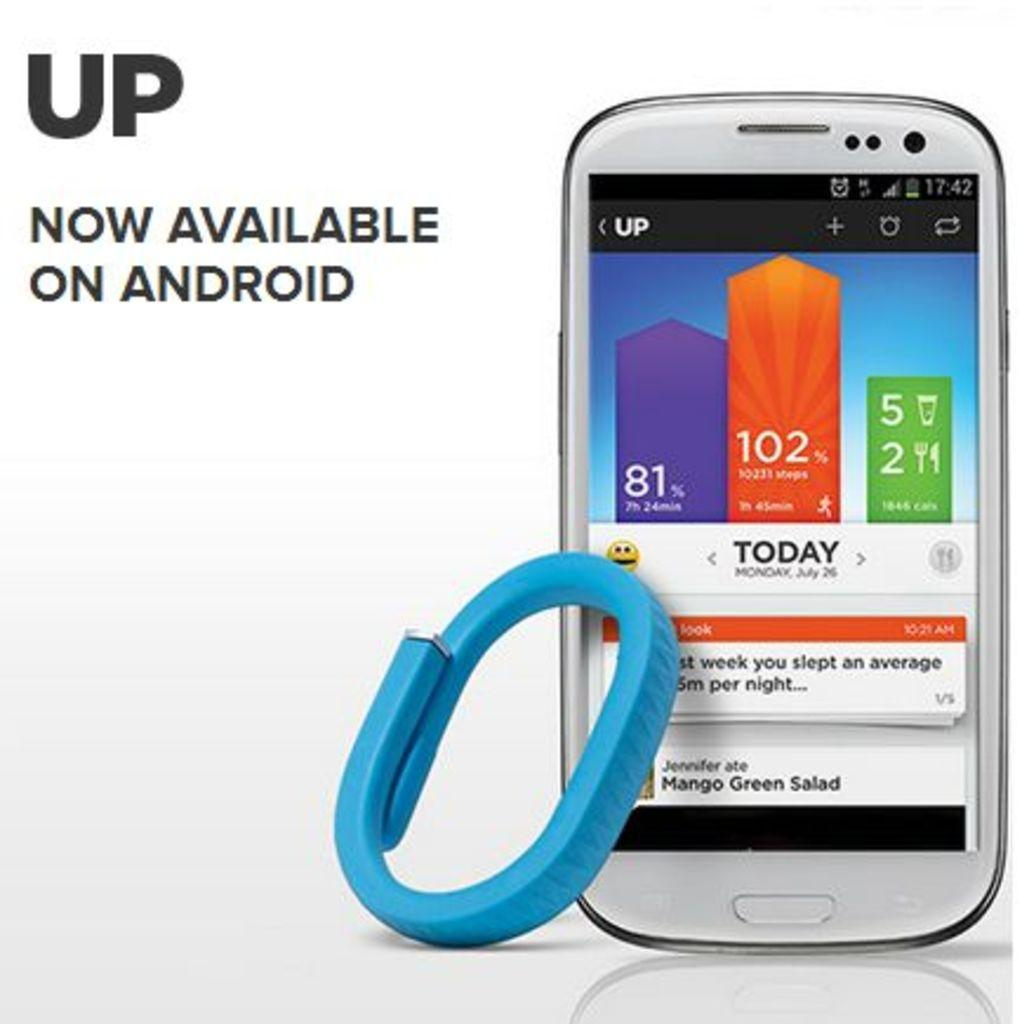<image>
Relay a brief, clear account of the picture shown. A phone screen shows the day as Monday. 